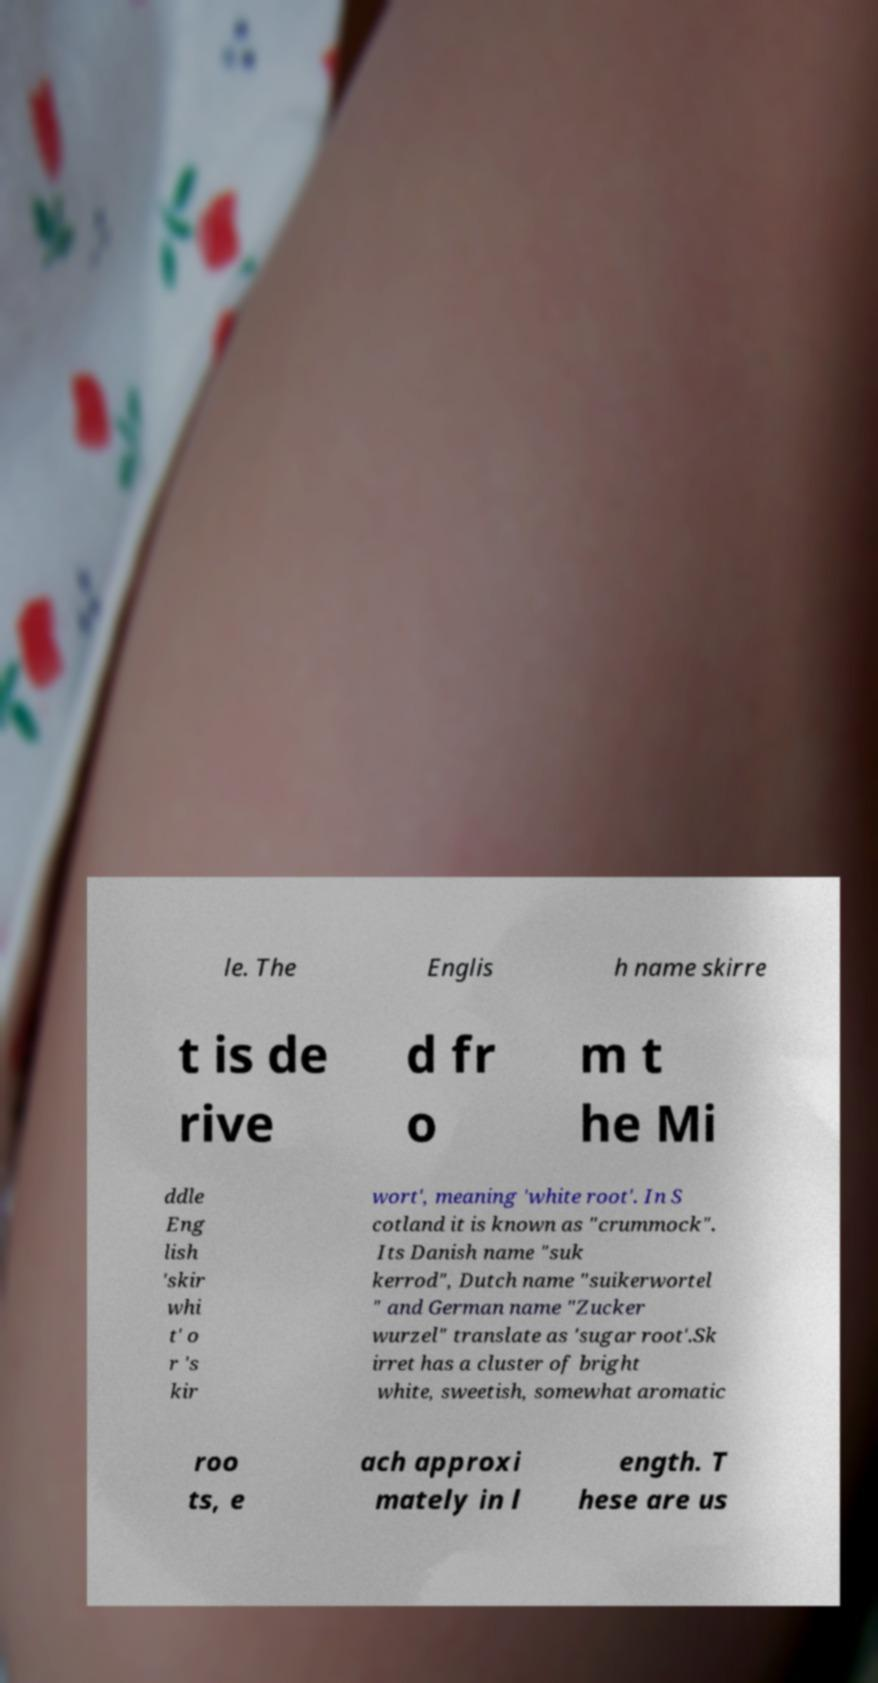Can you read and provide the text displayed in the image?This photo seems to have some interesting text. Can you extract and type it out for me? le. The Englis h name skirre t is de rive d fr o m t he Mi ddle Eng lish 'skir whi t' o r 's kir wort', meaning 'white root'. In S cotland it is known as "crummock". Its Danish name "suk kerrod", Dutch name "suikerwortel " and German name "Zucker wurzel" translate as 'sugar root'.Sk irret has a cluster of bright white, sweetish, somewhat aromatic roo ts, e ach approxi mately in l ength. T hese are us 